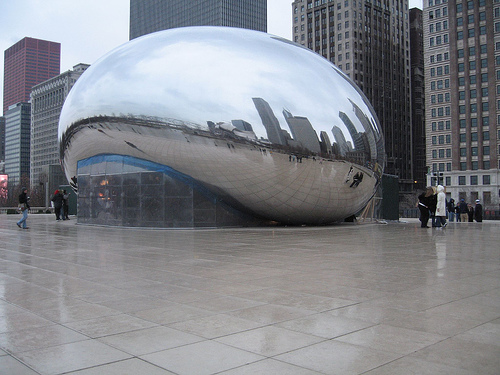<image>
Is there a building reflection in the statue? Yes. The building reflection is contained within or inside the statue, showing a containment relationship. 